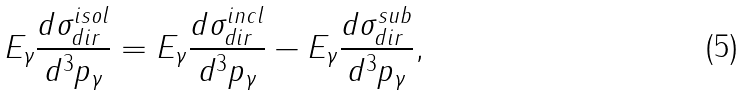Convert formula to latex. <formula><loc_0><loc_0><loc_500><loc_500>E _ { \gamma } \frac { d \sigma ^ { i s o l } _ { d i r } } { d ^ { 3 } p _ { \gamma } } = E _ { \gamma } \frac { d \sigma ^ { i n c l } _ { d i r } } { d ^ { 3 } p _ { \gamma } } - E _ { \gamma } \frac { d \sigma ^ { s u b } _ { d i r } } { d ^ { 3 } p _ { \gamma } } ,</formula> 